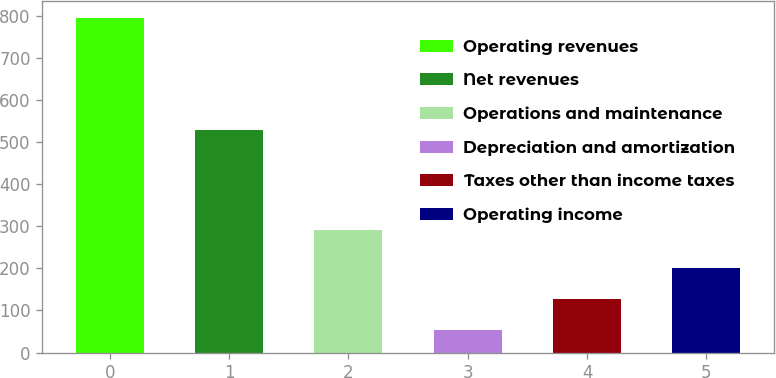<chart> <loc_0><loc_0><loc_500><loc_500><bar_chart><fcel>Operating revenues<fcel>Net revenues<fcel>Operations and maintenance<fcel>Depreciation and amortization<fcel>Taxes other than income taxes<fcel>Operating income<nl><fcel>795<fcel>528<fcel>291<fcel>53<fcel>127.2<fcel>201.4<nl></chart> 